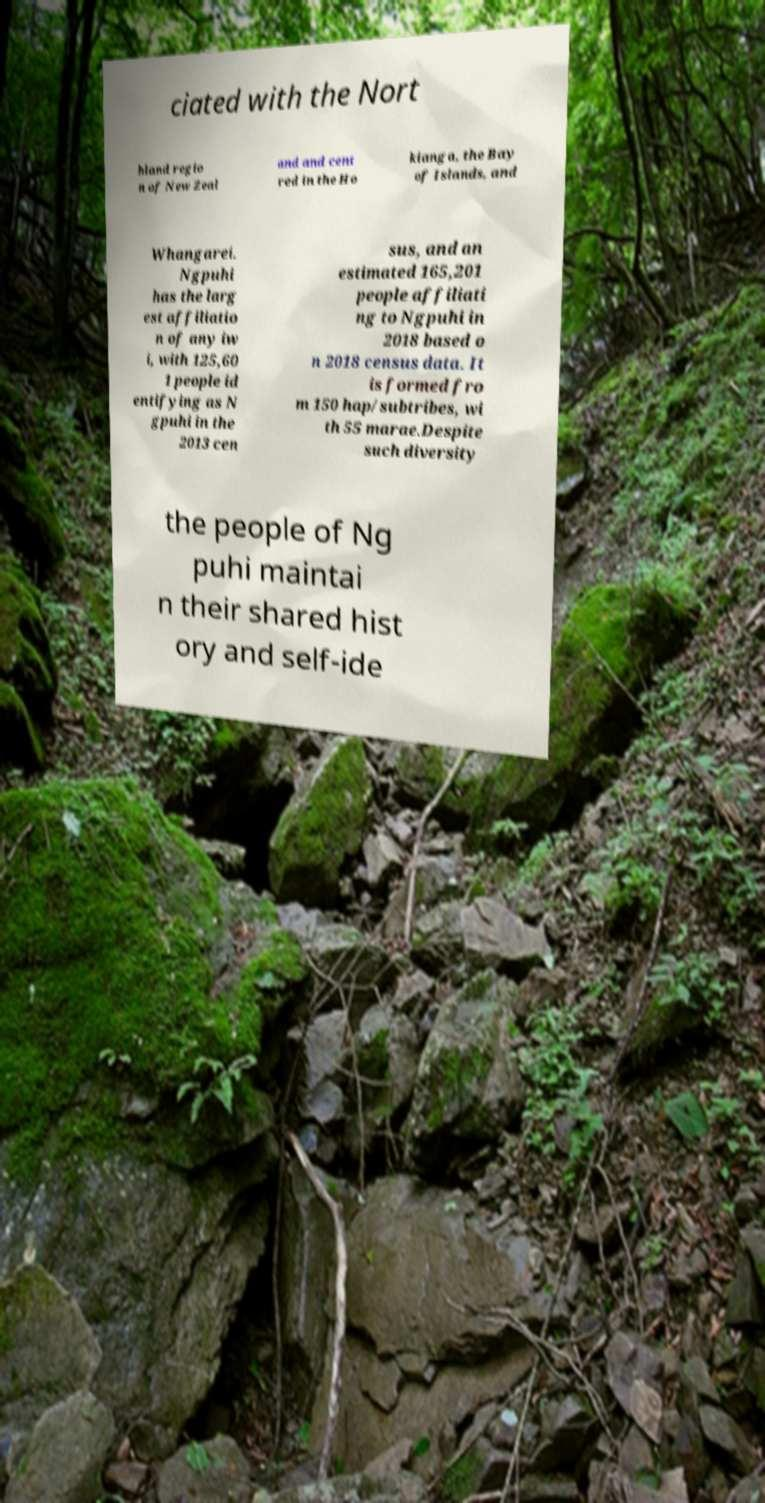Can you read and provide the text displayed in the image?This photo seems to have some interesting text. Can you extract and type it out for me? ciated with the Nort hland regio n of New Zeal and and cent red in the Ho kianga, the Bay of Islands, and Whangarei. Ngpuhi has the larg est affiliatio n of any iw i, with 125,60 1 people id entifying as N gpuhi in the 2013 cen sus, and an estimated 165,201 people affiliati ng to Ngpuhi in 2018 based o n 2018 census data. It is formed fro m 150 hap/subtribes, wi th 55 marae.Despite such diversity the people of Ng puhi maintai n their shared hist ory and self-ide 